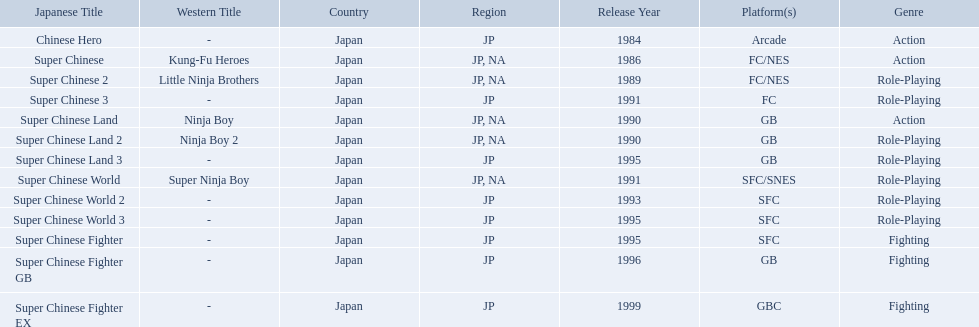Super ninja world was released in what countries? JP, NA. What was the original name for this title? Super Chinese World. Which titles were released in north america? Super Chinese, Super Chinese 2, Super Chinese Land, Super Chinese Land 2, Super Chinese World. Of those, which had the least releases? Super Chinese World. What japanese titles were released in the north american (na) region? Super Chinese, Super Chinese 2, Super Chinese Land, Super Chinese Land 2, Super Chinese World. Of those, which one was released most recently? Super Chinese World. 